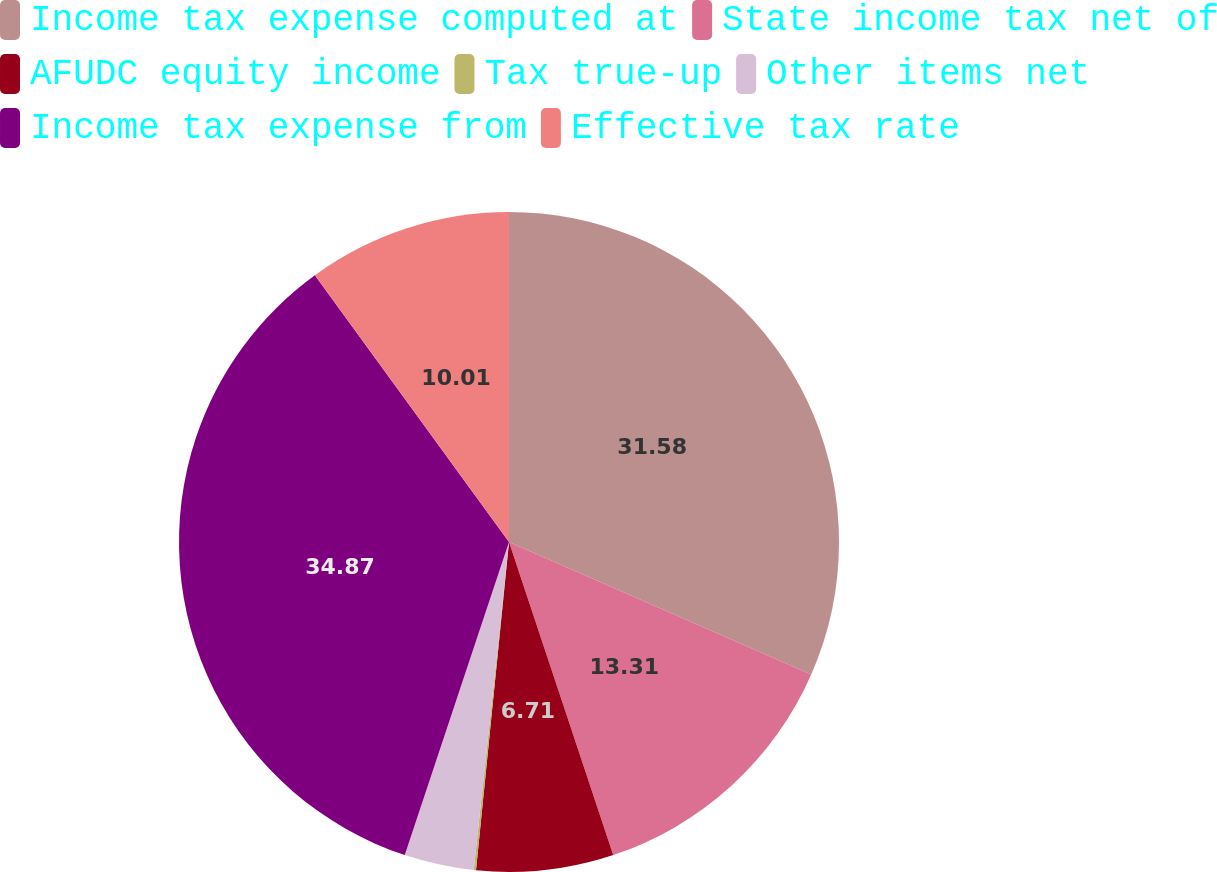Convert chart. <chart><loc_0><loc_0><loc_500><loc_500><pie_chart><fcel>Income tax expense computed at<fcel>State income tax net of<fcel>AFUDC equity income<fcel>Tax true-up<fcel>Other items net<fcel>Income tax expense from<fcel>Effective tax rate<nl><fcel>31.58%<fcel>13.31%<fcel>6.71%<fcel>0.11%<fcel>3.41%<fcel>34.88%<fcel>10.01%<nl></chart> 